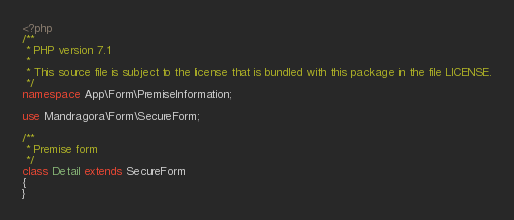Convert code to text. <code><loc_0><loc_0><loc_500><loc_500><_PHP_><?php
/**
 * PHP version 7.1
 *
 * This source file is subject to the license that is bundled with this package in the file LICENSE.
 */
namespace App\Form\PremiseInformation;

use Mandragora\Form\SecureForm;

/**
 * Premise form
 */
class Detail extends SecureForm
{
}</code> 